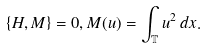Convert formula to latex. <formula><loc_0><loc_0><loc_500><loc_500>\{ H , M \} = 0 , M ( u ) = \int _ { \mathbb { T } } u ^ { 2 } \, d x .</formula> 